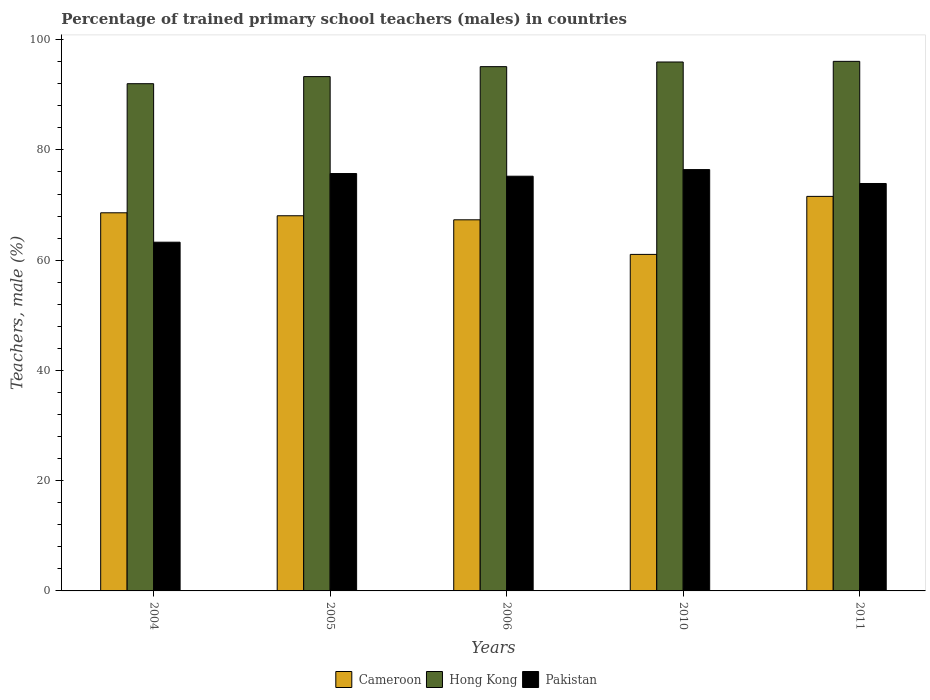How many different coloured bars are there?
Keep it short and to the point. 3. Are the number of bars per tick equal to the number of legend labels?
Provide a short and direct response. Yes. Are the number of bars on each tick of the X-axis equal?
Your response must be concise. Yes. How many bars are there on the 3rd tick from the right?
Give a very brief answer. 3. What is the label of the 2nd group of bars from the left?
Make the answer very short. 2005. In how many cases, is the number of bars for a given year not equal to the number of legend labels?
Ensure brevity in your answer.  0. What is the percentage of trained primary school teachers (males) in Cameroon in 2011?
Offer a very short reply. 71.57. Across all years, what is the maximum percentage of trained primary school teachers (males) in Cameroon?
Offer a very short reply. 71.57. Across all years, what is the minimum percentage of trained primary school teachers (males) in Pakistan?
Make the answer very short. 63.26. In which year was the percentage of trained primary school teachers (males) in Hong Kong maximum?
Offer a terse response. 2011. In which year was the percentage of trained primary school teachers (males) in Hong Kong minimum?
Keep it short and to the point. 2004. What is the total percentage of trained primary school teachers (males) in Pakistan in the graph?
Give a very brief answer. 364.54. What is the difference between the percentage of trained primary school teachers (males) in Pakistan in 2005 and that in 2011?
Ensure brevity in your answer.  1.81. What is the difference between the percentage of trained primary school teachers (males) in Pakistan in 2010 and the percentage of trained primary school teachers (males) in Hong Kong in 2005?
Provide a succinct answer. -16.87. What is the average percentage of trained primary school teachers (males) in Cameroon per year?
Your answer should be compact. 67.32. In the year 2010, what is the difference between the percentage of trained primary school teachers (males) in Pakistan and percentage of trained primary school teachers (males) in Hong Kong?
Make the answer very short. -19.52. What is the ratio of the percentage of trained primary school teachers (males) in Hong Kong in 2005 to that in 2010?
Keep it short and to the point. 0.97. Is the percentage of trained primary school teachers (males) in Hong Kong in 2004 less than that in 2005?
Provide a short and direct response. Yes. Is the difference between the percentage of trained primary school teachers (males) in Pakistan in 2005 and 2011 greater than the difference between the percentage of trained primary school teachers (males) in Hong Kong in 2005 and 2011?
Your answer should be compact. Yes. What is the difference between the highest and the second highest percentage of trained primary school teachers (males) in Cameroon?
Give a very brief answer. 2.98. What is the difference between the highest and the lowest percentage of trained primary school teachers (males) in Cameroon?
Ensure brevity in your answer.  10.52. What does the 2nd bar from the right in 2010 represents?
Make the answer very short. Hong Kong. How many bars are there?
Provide a succinct answer. 15. How many years are there in the graph?
Ensure brevity in your answer.  5. Does the graph contain any zero values?
Offer a very short reply. No. Does the graph contain grids?
Your answer should be very brief. No. Where does the legend appear in the graph?
Your response must be concise. Bottom center. How are the legend labels stacked?
Give a very brief answer. Horizontal. What is the title of the graph?
Keep it short and to the point. Percentage of trained primary school teachers (males) in countries. Does "Lebanon" appear as one of the legend labels in the graph?
Your response must be concise. No. What is the label or title of the Y-axis?
Offer a terse response. Teachers, male (%). What is the Teachers, male (%) of Cameroon in 2004?
Your answer should be very brief. 68.59. What is the Teachers, male (%) in Hong Kong in 2004?
Offer a very short reply. 92.01. What is the Teachers, male (%) of Pakistan in 2004?
Offer a very short reply. 63.26. What is the Teachers, male (%) of Cameroon in 2005?
Ensure brevity in your answer.  68.06. What is the Teachers, male (%) in Hong Kong in 2005?
Make the answer very short. 93.3. What is the Teachers, male (%) in Pakistan in 2005?
Your answer should be very brief. 75.71. What is the Teachers, male (%) of Cameroon in 2006?
Keep it short and to the point. 67.32. What is the Teachers, male (%) in Hong Kong in 2006?
Provide a short and direct response. 95.1. What is the Teachers, male (%) of Pakistan in 2006?
Provide a short and direct response. 75.23. What is the Teachers, male (%) of Cameroon in 2010?
Provide a succinct answer. 61.04. What is the Teachers, male (%) in Hong Kong in 2010?
Make the answer very short. 95.95. What is the Teachers, male (%) in Pakistan in 2010?
Keep it short and to the point. 76.43. What is the Teachers, male (%) of Cameroon in 2011?
Provide a short and direct response. 71.57. What is the Teachers, male (%) of Hong Kong in 2011?
Give a very brief answer. 96.06. What is the Teachers, male (%) of Pakistan in 2011?
Offer a very short reply. 73.91. Across all years, what is the maximum Teachers, male (%) of Cameroon?
Give a very brief answer. 71.57. Across all years, what is the maximum Teachers, male (%) in Hong Kong?
Make the answer very short. 96.06. Across all years, what is the maximum Teachers, male (%) of Pakistan?
Provide a succinct answer. 76.43. Across all years, what is the minimum Teachers, male (%) in Cameroon?
Provide a short and direct response. 61.04. Across all years, what is the minimum Teachers, male (%) in Hong Kong?
Make the answer very short. 92.01. Across all years, what is the minimum Teachers, male (%) in Pakistan?
Provide a short and direct response. 63.26. What is the total Teachers, male (%) in Cameroon in the graph?
Offer a very short reply. 336.58. What is the total Teachers, male (%) in Hong Kong in the graph?
Make the answer very short. 472.42. What is the total Teachers, male (%) in Pakistan in the graph?
Provide a short and direct response. 364.54. What is the difference between the Teachers, male (%) of Cameroon in 2004 and that in 2005?
Provide a short and direct response. 0.54. What is the difference between the Teachers, male (%) in Hong Kong in 2004 and that in 2005?
Offer a very short reply. -1.29. What is the difference between the Teachers, male (%) of Pakistan in 2004 and that in 2005?
Offer a very short reply. -12.45. What is the difference between the Teachers, male (%) in Cameroon in 2004 and that in 2006?
Offer a terse response. 1.27. What is the difference between the Teachers, male (%) in Hong Kong in 2004 and that in 2006?
Keep it short and to the point. -3.09. What is the difference between the Teachers, male (%) of Pakistan in 2004 and that in 2006?
Make the answer very short. -11.97. What is the difference between the Teachers, male (%) in Cameroon in 2004 and that in 2010?
Provide a succinct answer. 7.55. What is the difference between the Teachers, male (%) in Hong Kong in 2004 and that in 2010?
Give a very brief answer. -3.94. What is the difference between the Teachers, male (%) in Pakistan in 2004 and that in 2010?
Make the answer very short. -13.17. What is the difference between the Teachers, male (%) of Cameroon in 2004 and that in 2011?
Offer a terse response. -2.98. What is the difference between the Teachers, male (%) in Hong Kong in 2004 and that in 2011?
Provide a short and direct response. -4.05. What is the difference between the Teachers, male (%) in Pakistan in 2004 and that in 2011?
Give a very brief answer. -10.65. What is the difference between the Teachers, male (%) of Cameroon in 2005 and that in 2006?
Give a very brief answer. 0.73. What is the difference between the Teachers, male (%) of Hong Kong in 2005 and that in 2006?
Offer a terse response. -1.81. What is the difference between the Teachers, male (%) of Pakistan in 2005 and that in 2006?
Keep it short and to the point. 0.49. What is the difference between the Teachers, male (%) in Cameroon in 2005 and that in 2010?
Keep it short and to the point. 7.01. What is the difference between the Teachers, male (%) in Hong Kong in 2005 and that in 2010?
Provide a short and direct response. -2.65. What is the difference between the Teachers, male (%) of Pakistan in 2005 and that in 2010?
Provide a succinct answer. -0.72. What is the difference between the Teachers, male (%) of Cameroon in 2005 and that in 2011?
Provide a short and direct response. -3.51. What is the difference between the Teachers, male (%) of Hong Kong in 2005 and that in 2011?
Your answer should be very brief. -2.77. What is the difference between the Teachers, male (%) in Pakistan in 2005 and that in 2011?
Your answer should be very brief. 1.81. What is the difference between the Teachers, male (%) of Cameroon in 2006 and that in 2010?
Make the answer very short. 6.28. What is the difference between the Teachers, male (%) of Hong Kong in 2006 and that in 2010?
Keep it short and to the point. -0.84. What is the difference between the Teachers, male (%) in Pakistan in 2006 and that in 2010?
Give a very brief answer. -1.2. What is the difference between the Teachers, male (%) of Cameroon in 2006 and that in 2011?
Provide a succinct answer. -4.25. What is the difference between the Teachers, male (%) of Hong Kong in 2006 and that in 2011?
Provide a short and direct response. -0.96. What is the difference between the Teachers, male (%) of Pakistan in 2006 and that in 2011?
Your response must be concise. 1.32. What is the difference between the Teachers, male (%) of Cameroon in 2010 and that in 2011?
Offer a terse response. -10.52. What is the difference between the Teachers, male (%) in Hong Kong in 2010 and that in 2011?
Your response must be concise. -0.12. What is the difference between the Teachers, male (%) of Pakistan in 2010 and that in 2011?
Offer a terse response. 2.52. What is the difference between the Teachers, male (%) of Cameroon in 2004 and the Teachers, male (%) of Hong Kong in 2005?
Your answer should be very brief. -24.71. What is the difference between the Teachers, male (%) in Cameroon in 2004 and the Teachers, male (%) in Pakistan in 2005?
Ensure brevity in your answer.  -7.12. What is the difference between the Teachers, male (%) in Hong Kong in 2004 and the Teachers, male (%) in Pakistan in 2005?
Provide a short and direct response. 16.3. What is the difference between the Teachers, male (%) of Cameroon in 2004 and the Teachers, male (%) of Hong Kong in 2006?
Ensure brevity in your answer.  -26.51. What is the difference between the Teachers, male (%) of Cameroon in 2004 and the Teachers, male (%) of Pakistan in 2006?
Your answer should be compact. -6.64. What is the difference between the Teachers, male (%) of Hong Kong in 2004 and the Teachers, male (%) of Pakistan in 2006?
Your response must be concise. 16.78. What is the difference between the Teachers, male (%) in Cameroon in 2004 and the Teachers, male (%) in Hong Kong in 2010?
Offer a terse response. -27.36. What is the difference between the Teachers, male (%) in Cameroon in 2004 and the Teachers, male (%) in Pakistan in 2010?
Make the answer very short. -7.84. What is the difference between the Teachers, male (%) of Hong Kong in 2004 and the Teachers, male (%) of Pakistan in 2010?
Ensure brevity in your answer.  15.58. What is the difference between the Teachers, male (%) of Cameroon in 2004 and the Teachers, male (%) of Hong Kong in 2011?
Provide a short and direct response. -27.47. What is the difference between the Teachers, male (%) in Cameroon in 2004 and the Teachers, male (%) in Pakistan in 2011?
Keep it short and to the point. -5.32. What is the difference between the Teachers, male (%) in Hong Kong in 2004 and the Teachers, male (%) in Pakistan in 2011?
Your response must be concise. 18.1. What is the difference between the Teachers, male (%) of Cameroon in 2005 and the Teachers, male (%) of Hong Kong in 2006?
Offer a very short reply. -27.05. What is the difference between the Teachers, male (%) in Cameroon in 2005 and the Teachers, male (%) in Pakistan in 2006?
Provide a short and direct response. -7.17. What is the difference between the Teachers, male (%) in Hong Kong in 2005 and the Teachers, male (%) in Pakistan in 2006?
Give a very brief answer. 18.07. What is the difference between the Teachers, male (%) in Cameroon in 2005 and the Teachers, male (%) in Hong Kong in 2010?
Make the answer very short. -27.89. What is the difference between the Teachers, male (%) of Cameroon in 2005 and the Teachers, male (%) of Pakistan in 2010?
Your response must be concise. -8.37. What is the difference between the Teachers, male (%) in Hong Kong in 2005 and the Teachers, male (%) in Pakistan in 2010?
Make the answer very short. 16.87. What is the difference between the Teachers, male (%) in Cameroon in 2005 and the Teachers, male (%) in Hong Kong in 2011?
Make the answer very short. -28.01. What is the difference between the Teachers, male (%) of Cameroon in 2005 and the Teachers, male (%) of Pakistan in 2011?
Provide a short and direct response. -5.85. What is the difference between the Teachers, male (%) of Hong Kong in 2005 and the Teachers, male (%) of Pakistan in 2011?
Your answer should be compact. 19.39. What is the difference between the Teachers, male (%) of Cameroon in 2006 and the Teachers, male (%) of Hong Kong in 2010?
Offer a very short reply. -28.63. What is the difference between the Teachers, male (%) of Cameroon in 2006 and the Teachers, male (%) of Pakistan in 2010?
Offer a very short reply. -9.11. What is the difference between the Teachers, male (%) in Hong Kong in 2006 and the Teachers, male (%) in Pakistan in 2010?
Keep it short and to the point. 18.67. What is the difference between the Teachers, male (%) in Cameroon in 2006 and the Teachers, male (%) in Hong Kong in 2011?
Provide a succinct answer. -28.74. What is the difference between the Teachers, male (%) of Cameroon in 2006 and the Teachers, male (%) of Pakistan in 2011?
Offer a very short reply. -6.59. What is the difference between the Teachers, male (%) of Hong Kong in 2006 and the Teachers, male (%) of Pakistan in 2011?
Provide a short and direct response. 21.2. What is the difference between the Teachers, male (%) in Cameroon in 2010 and the Teachers, male (%) in Hong Kong in 2011?
Your answer should be very brief. -35.02. What is the difference between the Teachers, male (%) of Cameroon in 2010 and the Teachers, male (%) of Pakistan in 2011?
Give a very brief answer. -12.86. What is the difference between the Teachers, male (%) of Hong Kong in 2010 and the Teachers, male (%) of Pakistan in 2011?
Provide a short and direct response. 22.04. What is the average Teachers, male (%) in Cameroon per year?
Your response must be concise. 67.32. What is the average Teachers, male (%) of Hong Kong per year?
Your answer should be compact. 94.48. What is the average Teachers, male (%) of Pakistan per year?
Provide a succinct answer. 72.91. In the year 2004, what is the difference between the Teachers, male (%) in Cameroon and Teachers, male (%) in Hong Kong?
Your answer should be compact. -23.42. In the year 2004, what is the difference between the Teachers, male (%) of Cameroon and Teachers, male (%) of Pakistan?
Your answer should be very brief. 5.33. In the year 2004, what is the difference between the Teachers, male (%) in Hong Kong and Teachers, male (%) in Pakistan?
Your answer should be compact. 28.75. In the year 2005, what is the difference between the Teachers, male (%) of Cameroon and Teachers, male (%) of Hong Kong?
Make the answer very short. -25.24. In the year 2005, what is the difference between the Teachers, male (%) of Cameroon and Teachers, male (%) of Pakistan?
Offer a very short reply. -7.66. In the year 2005, what is the difference between the Teachers, male (%) of Hong Kong and Teachers, male (%) of Pakistan?
Your answer should be very brief. 17.58. In the year 2006, what is the difference between the Teachers, male (%) of Cameroon and Teachers, male (%) of Hong Kong?
Make the answer very short. -27.78. In the year 2006, what is the difference between the Teachers, male (%) of Cameroon and Teachers, male (%) of Pakistan?
Ensure brevity in your answer.  -7.91. In the year 2006, what is the difference between the Teachers, male (%) in Hong Kong and Teachers, male (%) in Pakistan?
Give a very brief answer. 19.88. In the year 2010, what is the difference between the Teachers, male (%) of Cameroon and Teachers, male (%) of Hong Kong?
Your answer should be compact. -34.9. In the year 2010, what is the difference between the Teachers, male (%) of Cameroon and Teachers, male (%) of Pakistan?
Give a very brief answer. -15.38. In the year 2010, what is the difference between the Teachers, male (%) of Hong Kong and Teachers, male (%) of Pakistan?
Offer a very short reply. 19.52. In the year 2011, what is the difference between the Teachers, male (%) of Cameroon and Teachers, male (%) of Hong Kong?
Make the answer very short. -24.5. In the year 2011, what is the difference between the Teachers, male (%) of Cameroon and Teachers, male (%) of Pakistan?
Provide a short and direct response. -2.34. In the year 2011, what is the difference between the Teachers, male (%) of Hong Kong and Teachers, male (%) of Pakistan?
Make the answer very short. 22.16. What is the ratio of the Teachers, male (%) in Cameroon in 2004 to that in 2005?
Provide a short and direct response. 1.01. What is the ratio of the Teachers, male (%) in Hong Kong in 2004 to that in 2005?
Offer a terse response. 0.99. What is the ratio of the Teachers, male (%) of Pakistan in 2004 to that in 2005?
Give a very brief answer. 0.84. What is the ratio of the Teachers, male (%) in Cameroon in 2004 to that in 2006?
Give a very brief answer. 1.02. What is the ratio of the Teachers, male (%) of Hong Kong in 2004 to that in 2006?
Provide a succinct answer. 0.97. What is the ratio of the Teachers, male (%) of Pakistan in 2004 to that in 2006?
Ensure brevity in your answer.  0.84. What is the ratio of the Teachers, male (%) of Cameroon in 2004 to that in 2010?
Your answer should be compact. 1.12. What is the ratio of the Teachers, male (%) of Pakistan in 2004 to that in 2010?
Your answer should be very brief. 0.83. What is the ratio of the Teachers, male (%) of Cameroon in 2004 to that in 2011?
Offer a terse response. 0.96. What is the ratio of the Teachers, male (%) in Hong Kong in 2004 to that in 2011?
Offer a very short reply. 0.96. What is the ratio of the Teachers, male (%) of Pakistan in 2004 to that in 2011?
Your response must be concise. 0.86. What is the ratio of the Teachers, male (%) of Cameroon in 2005 to that in 2006?
Offer a terse response. 1.01. What is the ratio of the Teachers, male (%) of Hong Kong in 2005 to that in 2006?
Your answer should be compact. 0.98. What is the ratio of the Teachers, male (%) in Cameroon in 2005 to that in 2010?
Your answer should be very brief. 1.11. What is the ratio of the Teachers, male (%) in Hong Kong in 2005 to that in 2010?
Ensure brevity in your answer.  0.97. What is the ratio of the Teachers, male (%) of Pakistan in 2005 to that in 2010?
Your answer should be compact. 0.99. What is the ratio of the Teachers, male (%) in Cameroon in 2005 to that in 2011?
Make the answer very short. 0.95. What is the ratio of the Teachers, male (%) in Hong Kong in 2005 to that in 2011?
Your response must be concise. 0.97. What is the ratio of the Teachers, male (%) of Pakistan in 2005 to that in 2011?
Keep it short and to the point. 1.02. What is the ratio of the Teachers, male (%) in Cameroon in 2006 to that in 2010?
Your answer should be compact. 1.1. What is the ratio of the Teachers, male (%) of Hong Kong in 2006 to that in 2010?
Your answer should be compact. 0.99. What is the ratio of the Teachers, male (%) of Pakistan in 2006 to that in 2010?
Make the answer very short. 0.98. What is the ratio of the Teachers, male (%) in Cameroon in 2006 to that in 2011?
Offer a terse response. 0.94. What is the ratio of the Teachers, male (%) in Pakistan in 2006 to that in 2011?
Your answer should be very brief. 1.02. What is the ratio of the Teachers, male (%) of Cameroon in 2010 to that in 2011?
Your answer should be very brief. 0.85. What is the ratio of the Teachers, male (%) in Pakistan in 2010 to that in 2011?
Your answer should be compact. 1.03. What is the difference between the highest and the second highest Teachers, male (%) in Cameroon?
Ensure brevity in your answer.  2.98. What is the difference between the highest and the second highest Teachers, male (%) of Hong Kong?
Give a very brief answer. 0.12. What is the difference between the highest and the second highest Teachers, male (%) of Pakistan?
Offer a terse response. 0.72. What is the difference between the highest and the lowest Teachers, male (%) of Cameroon?
Provide a short and direct response. 10.52. What is the difference between the highest and the lowest Teachers, male (%) of Hong Kong?
Your answer should be compact. 4.05. What is the difference between the highest and the lowest Teachers, male (%) of Pakistan?
Ensure brevity in your answer.  13.17. 